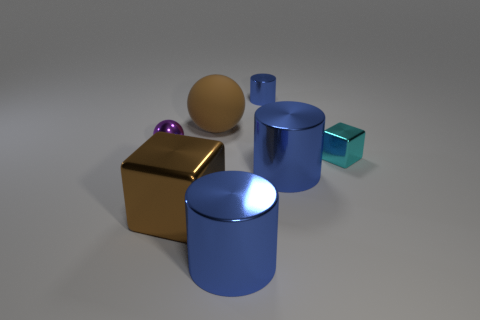There is a block that is the same color as the rubber ball; what is its size?
Offer a very short reply. Large. There is a thing that is the same color as the large shiny block; what is its shape?
Keep it short and to the point. Sphere. What size is the blue cylinder that is behind the blue metallic cylinder that is on the right side of the cylinder behind the tiny cyan block?
Your answer should be very brief. Small. What material is the large sphere?
Make the answer very short. Rubber. Do the big brown sphere and the cylinder behind the brown matte sphere have the same material?
Provide a succinct answer. No. Is there anything else that has the same color as the tiny ball?
Offer a terse response. No. Are there any balls in front of the large metal thing that is in front of the big block in front of the tiny blue metallic cylinder?
Offer a terse response. No. The rubber thing is what color?
Offer a terse response. Brown. There is a small purple metal thing; are there any big blue metallic cylinders behind it?
Your answer should be compact. No. Does the small purple thing have the same shape as the blue object in front of the large brown metal block?
Your answer should be very brief. No. 